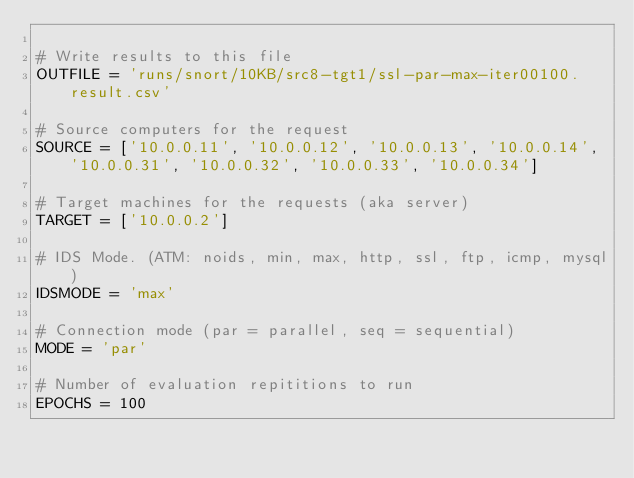<code> <loc_0><loc_0><loc_500><loc_500><_Python_>
# Write results to this file
OUTFILE = 'runs/snort/10KB/src8-tgt1/ssl-par-max-iter00100.result.csv'

# Source computers for the request
SOURCE = ['10.0.0.11', '10.0.0.12', '10.0.0.13', '10.0.0.14', '10.0.0.31', '10.0.0.32', '10.0.0.33', '10.0.0.34']

# Target machines for the requests (aka server)
TARGET = ['10.0.0.2']

# IDS Mode. (ATM: noids, min, max, http, ssl, ftp, icmp, mysql)
IDSMODE = 'max'

# Connection mode (par = parallel, seq = sequential)
MODE = 'par'

# Number of evaluation repititions to run
EPOCHS = 100
</code> 